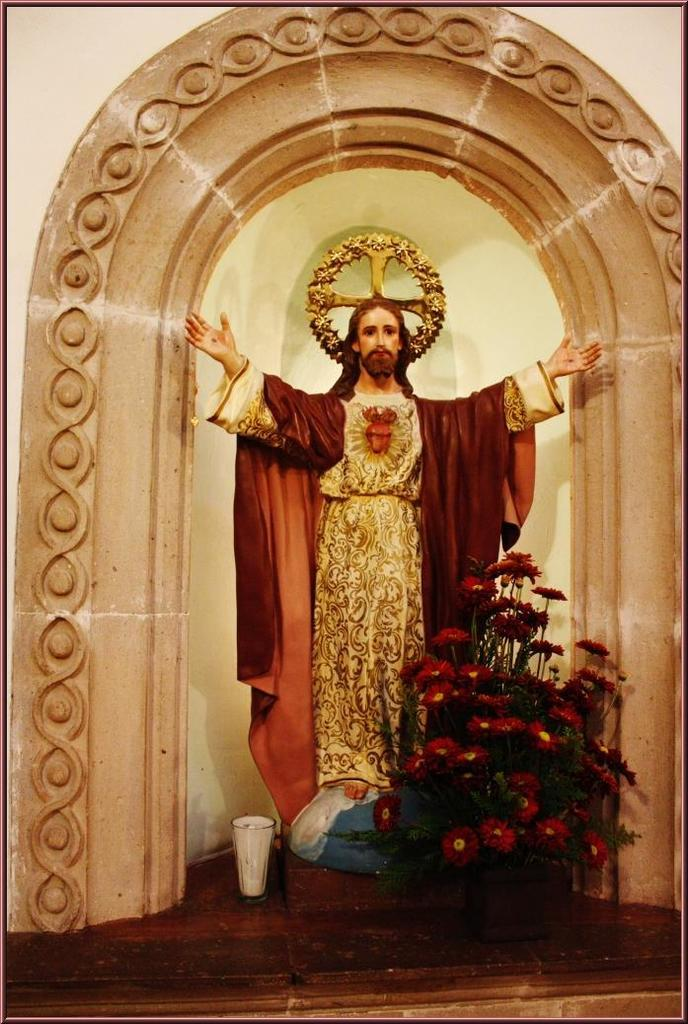What is the main subject of the image? There is a statue of Jesus Christ in the image. What is placed in front of the statue? There is a bouquet in front of the statue. What is depicted in front of the statue besides the bouquet? There is a depiction of glass in front of the statue. What can be seen in the background of the image? There is a wall in the background of the image. How does the beginner fold the coil in the image? There is no coil or folding activity present in the image; it features a statue of Jesus Christ with a bouquet and a depiction of glass in front of it. 